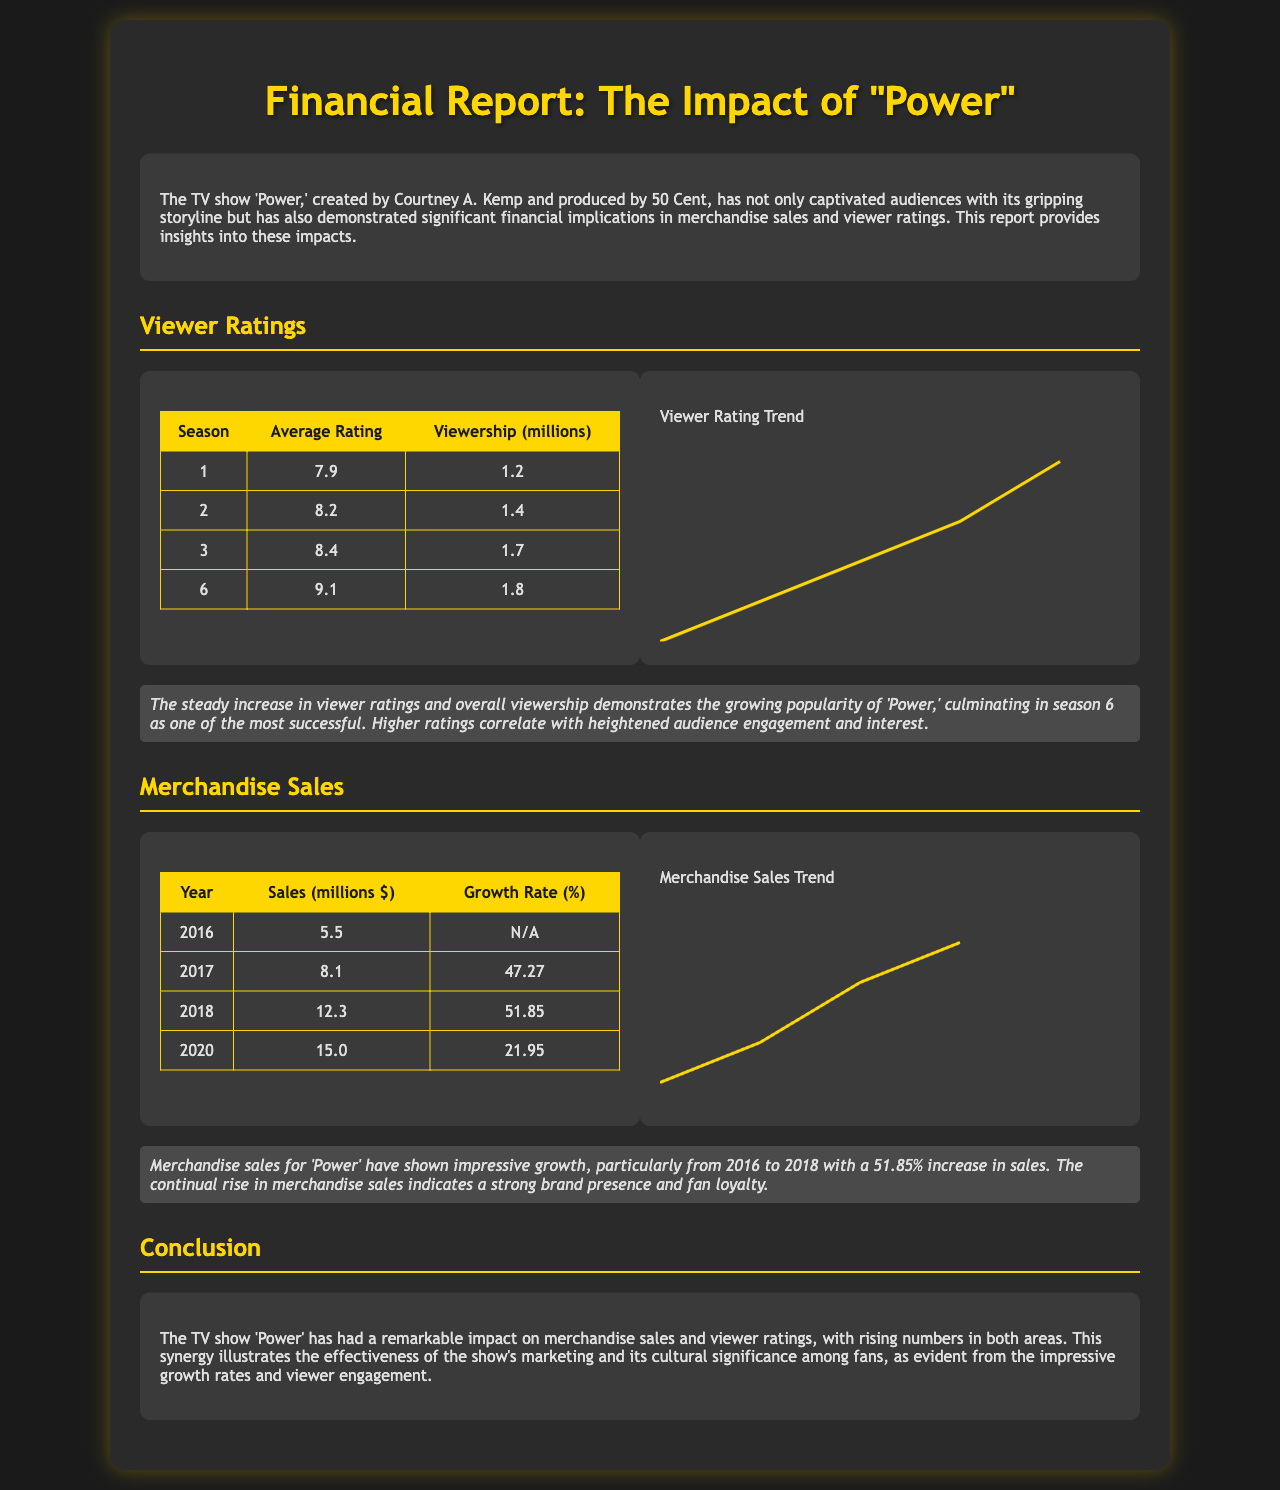What is the average rating of Season 3? The average rating of Season 3 is explicitly stated in the table, which is 8.4.
Answer: 8.4 What was the viewership for Season 6? The viewership for Season 6 is given in the table, which states it was 1.8 million.
Answer: 1.8 million What year saw a 51.85% growth in merchandise sales? The document indicates that merchandise sales increased by 51.85% between the years 2017 and 2018.
Answer: 2018 What was the sales figure for merchandise in 2020? The document provides the sales figure for 2020, which is stated as 15.0 million dollars.
Answer: 15.0 million Which season has the highest viewer rating? The viewer ratings show that Season 6 has the highest rating at 9.1 according to the table provided.
Answer: 9.1 What was the initial merchandise sales figure in 2016? The sales figure for merchandise in 2016 is clearly listed as 5.5 million dollars.
Answer: 5.5 million In which section is the analysis of viewer ratings found? The analysis of viewer ratings is located within the Viewer Ratings section of the document.
Answer: Viewer Ratings How does merchandise sales relate to fan loyalty? The analysis states that continual rise in merchandise sales indicates a strong brand presence and fan loyalty.
Answer: Strong brand presence and fan loyalty 